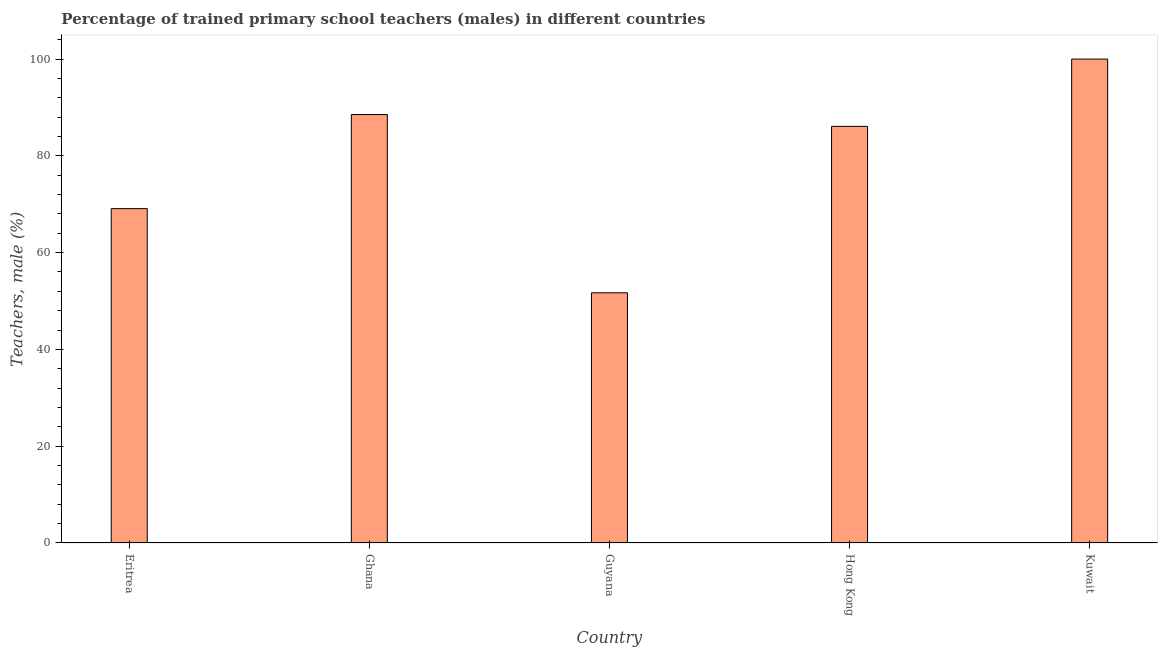Does the graph contain any zero values?
Make the answer very short. No. What is the title of the graph?
Make the answer very short. Percentage of trained primary school teachers (males) in different countries. What is the label or title of the Y-axis?
Provide a short and direct response. Teachers, male (%). What is the percentage of trained male teachers in Kuwait?
Give a very brief answer. 100. Across all countries, what is the maximum percentage of trained male teachers?
Give a very brief answer. 100. Across all countries, what is the minimum percentage of trained male teachers?
Make the answer very short. 51.7. In which country was the percentage of trained male teachers maximum?
Keep it short and to the point. Kuwait. In which country was the percentage of trained male teachers minimum?
Offer a terse response. Guyana. What is the sum of the percentage of trained male teachers?
Your answer should be compact. 395.43. What is the difference between the percentage of trained male teachers in Eritrea and Ghana?
Make the answer very short. -19.44. What is the average percentage of trained male teachers per country?
Your answer should be very brief. 79.08. What is the median percentage of trained male teachers?
Keep it short and to the point. 86.1. What is the ratio of the percentage of trained male teachers in Eritrea to that in Kuwait?
Keep it short and to the point. 0.69. Is the difference between the percentage of trained male teachers in Eritrea and Guyana greater than the difference between any two countries?
Keep it short and to the point. No. What is the difference between the highest and the second highest percentage of trained male teachers?
Your answer should be compact. 11.46. Is the sum of the percentage of trained male teachers in Eritrea and Guyana greater than the maximum percentage of trained male teachers across all countries?
Your response must be concise. Yes. What is the difference between the highest and the lowest percentage of trained male teachers?
Give a very brief answer. 48.3. In how many countries, is the percentage of trained male teachers greater than the average percentage of trained male teachers taken over all countries?
Your answer should be compact. 3. How many bars are there?
Provide a short and direct response. 5. How many countries are there in the graph?
Provide a short and direct response. 5. What is the difference between two consecutive major ticks on the Y-axis?
Your answer should be compact. 20. What is the Teachers, male (%) in Eritrea?
Make the answer very short. 69.09. What is the Teachers, male (%) in Ghana?
Make the answer very short. 88.54. What is the Teachers, male (%) in Guyana?
Offer a very short reply. 51.7. What is the Teachers, male (%) of Hong Kong?
Offer a very short reply. 86.1. What is the difference between the Teachers, male (%) in Eritrea and Ghana?
Make the answer very short. -19.44. What is the difference between the Teachers, male (%) in Eritrea and Guyana?
Provide a succinct answer. 17.39. What is the difference between the Teachers, male (%) in Eritrea and Hong Kong?
Offer a terse response. -17.01. What is the difference between the Teachers, male (%) in Eritrea and Kuwait?
Your answer should be compact. -30.91. What is the difference between the Teachers, male (%) in Ghana and Guyana?
Offer a terse response. 36.84. What is the difference between the Teachers, male (%) in Ghana and Hong Kong?
Provide a succinct answer. 2.44. What is the difference between the Teachers, male (%) in Ghana and Kuwait?
Give a very brief answer. -11.46. What is the difference between the Teachers, male (%) in Guyana and Hong Kong?
Keep it short and to the point. -34.4. What is the difference between the Teachers, male (%) in Guyana and Kuwait?
Offer a terse response. -48.3. What is the difference between the Teachers, male (%) in Hong Kong and Kuwait?
Make the answer very short. -13.9. What is the ratio of the Teachers, male (%) in Eritrea to that in Ghana?
Your answer should be very brief. 0.78. What is the ratio of the Teachers, male (%) in Eritrea to that in Guyana?
Ensure brevity in your answer.  1.34. What is the ratio of the Teachers, male (%) in Eritrea to that in Hong Kong?
Make the answer very short. 0.8. What is the ratio of the Teachers, male (%) in Eritrea to that in Kuwait?
Provide a succinct answer. 0.69. What is the ratio of the Teachers, male (%) in Ghana to that in Guyana?
Provide a short and direct response. 1.71. What is the ratio of the Teachers, male (%) in Ghana to that in Hong Kong?
Ensure brevity in your answer.  1.03. What is the ratio of the Teachers, male (%) in Ghana to that in Kuwait?
Ensure brevity in your answer.  0.89. What is the ratio of the Teachers, male (%) in Guyana to that in Kuwait?
Offer a terse response. 0.52. What is the ratio of the Teachers, male (%) in Hong Kong to that in Kuwait?
Keep it short and to the point. 0.86. 